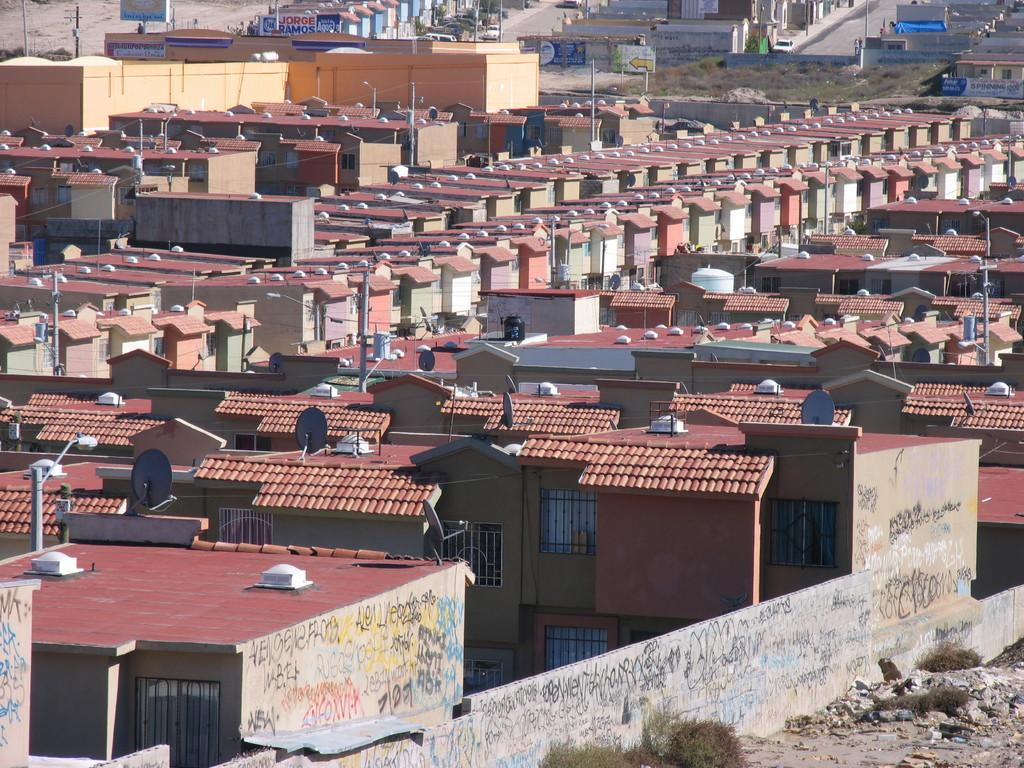What type of structures can be seen in the image? There are many buildings with windows in the image. What is written or displayed on the walls of the buildings? There is text on the walls of the buildings. What type of barrier surrounds the area in the image? There is a compound wall in the image. What type of equipment is visible on the roofs of the buildings? Dish antennas are visible in the image. What are the tall, slender structures with lights in the image? Light poles are present in the image. Can you see the queen's vein in the image? There is no queen or vein present in the image; it features buildings, text, a compound wall, dish antennas, and light poles. 